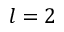Convert formula to latex. <formula><loc_0><loc_0><loc_500><loc_500>l = 2</formula> 